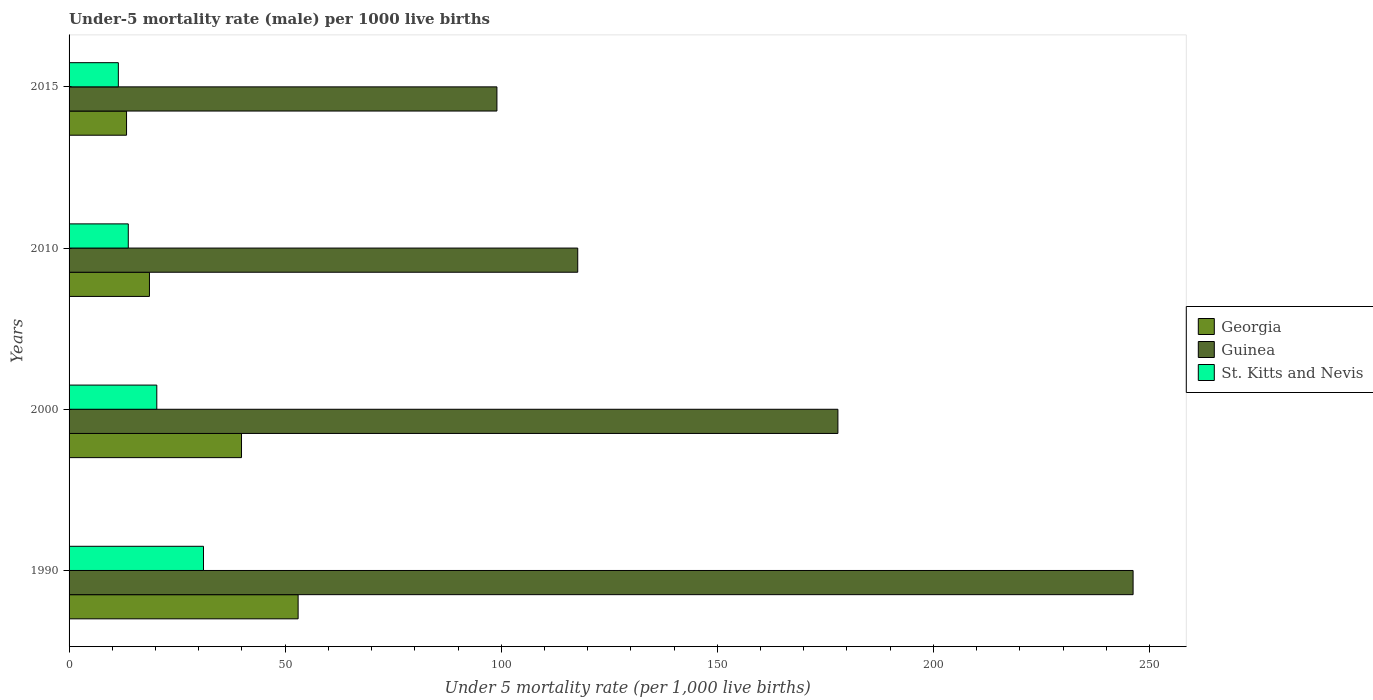How many different coloured bars are there?
Your answer should be compact. 3. How many groups of bars are there?
Your response must be concise. 4. What is the label of the 1st group of bars from the top?
Give a very brief answer. 2015. In how many cases, is the number of bars for a given year not equal to the number of legend labels?
Keep it short and to the point. 0. What is the under-five mortality rate in Guinea in 2010?
Provide a succinct answer. 117.7. In which year was the under-five mortality rate in Georgia minimum?
Make the answer very short. 2015. What is the total under-five mortality rate in Guinea in the graph?
Provide a succinct answer. 640.8. What is the difference between the under-five mortality rate in Georgia in 2000 and that in 2015?
Ensure brevity in your answer.  26.6. What is the difference between the under-five mortality rate in Georgia in 2000 and the under-five mortality rate in Guinea in 2015?
Give a very brief answer. -59.1. What is the average under-five mortality rate in Guinea per year?
Give a very brief answer. 160.2. In the year 2015, what is the difference between the under-five mortality rate in Guinea and under-five mortality rate in St. Kitts and Nevis?
Your answer should be very brief. 87.6. What is the ratio of the under-five mortality rate in Georgia in 1990 to that in 2000?
Provide a short and direct response. 1.33. What is the difference between the highest and the second highest under-five mortality rate in Guinea?
Your response must be concise. 68.3. What is the difference between the highest and the lowest under-five mortality rate in Georgia?
Make the answer very short. 39.7. In how many years, is the under-five mortality rate in Georgia greater than the average under-five mortality rate in Georgia taken over all years?
Give a very brief answer. 2. What does the 1st bar from the top in 2010 represents?
Provide a succinct answer. St. Kitts and Nevis. What does the 2nd bar from the bottom in 2015 represents?
Your response must be concise. Guinea. How many bars are there?
Provide a short and direct response. 12. Are all the bars in the graph horizontal?
Provide a short and direct response. Yes. Does the graph contain any zero values?
Make the answer very short. No. How many legend labels are there?
Keep it short and to the point. 3. How are the legend labels stacked?
Ensure brevity in your answer.  Vertical. What is the title of the graph?
Your response must be concise. Under-5 mortality rate (male) per 1000 live births. Does "Kosovo" appear as one of the legend labels in the graph?
Offer a very short reply. No. What is the label or title of the X-axis?
Provide a succinct answer. Under 5 mortality rate (per 1,0 live births). What is the label or title of the Y-axis?
Make the answer very short. Years. What is the Under 5 mortality rate (per 1,000 live births) in Guinea in 1990?
Give a very brief answer. 246.2. What is the Under 5 mortality rate (per 1,000 live births) in St. Kitts and Nevis in 1990?
Keep it short and to the point. 31.1. What is the Under 5 mortality rate (per 1,000 live births) in Georgia in 2000?
Make the answer very short. 39.9. What is the Under 5 mortality rate (per 1,000 live births) of Guinea in 2000?
Give a very brief answer. 177.9. What is the Under 5 mortality rate (per 1,000 live births) in St. Kitts and Nevis in 2000?
Offer a very short reply. 20.3. What is the Under 5 mortality rate (per 1,000 live births) of Guinea in 2010?
Your answer should be very brief. 117.7. What is the Under 5 mortality rate (per 1,000 live births) of St. Kitts and Nevis in 2010?
Provide a succinct answer. 13.7. What is the Under 5 mortality rate (per 1,000 live births) in St. Kitts and Nevis in 2015?
Ensure brevity in your answer.  11.4. Across all years, what is the maximum Under 5 mortality rate (per 1,000 live births) of Guinea?
Ensure brevity in your answer.  246.2. Across all years, what is the maximum Under 5 mortality rate (per 1,000 live births) of St. Kitts and Nevis?
Give a very brief answer. 31.1. What is the total Under 5 mortality rate (per 1,000 live births) of Georgia in the graph?
Give a very brief answer. 124.8. What is the total Under 5 mortality rate (per 1,000 live births) of Guinea in the graph?
Offer a terse response. 640.8. What is the total Under 5 mortality rate (per 1,000 live births) in St. Kitts and Nevis in the graph?
Keep it short and to the point. 76.5. What is the difference between the Under 5 mortality rate (per 1,000 live births) of Georgia in 1990 and that in 2000?
Your response must be concise. 13.1. What is the difference between the Under 5 mortality rate (per 1,000 live births) of Guinea in 1990 and that in 2000?
Provide a succinct answer. 68.3. What is the difference between the Under 5 mortality rate (per 1,000 live births) in Georgia in 1990 and that in 2010?
Your answer should be compact. 34.4. What is the difference between the Under 5 mortality rate (per 1,000 live births) in Guinea in 1990 and that in 2010?
Provide a succinct answer. 128.5. What is the difference between the Under 5 mortality rate (per 1,000 live births) in Georgia in 1990 and that in 2015?
Provide a succinct answer. 39.7. What is the difference between the Under 5 mortality rate (per 1,000 live births) in Guinea in 1990 and that in 2015?
Offer a terse response. 147.2. What is the difference between the Under 5 mortality rate (per 1,000 live births) of St. Kitts and Nevis in 1990 and that in 2015?
Your answer should be compact. 19.7. What is the difference between the Under 5 mortality rate (per 1,000 live births) of Georgia in 2000 and that in 2010?
Ensure brevity in your answer.  21.3. What is the difference between the Under 5 mortality rate (per 1,000 live births) of Guinea in 2000 and that in 2010?
Keep it short and to the point. 60.2. What is the difference between the Under 5 mortality rate (per 1,000 live births) in Georgia in 2000 and that in 2015?
Offer a terse response. 26.6. What is the difference between the Under 5 mortality rate (per 1,000 live births) of Guinea in 2000 and that in 2015?
Your answer should be compact. 78.9. What is the difference between the Under 5 mortality rate (per 1,000 live births) in St. Kitts and Nevis in 2000 and that in 2015?
Provide a short and direct response. 8.9. What is the difference between the Under 5 mortality rate (per 1,000 live births) in Georgia in 2010 and that in 2015?
Provide a short and direct response. 5.3. What is the difference between the Under 5 mortality rate (per 1,000 live births) in Guinea in 2010 and that in 2015?
Your answer should be very brief. 18.7. What is the difference between the Under 5 mortality rate (per 1,000 live births) of St. Kitts and Nevis in 2010 and that in 2015?
Your answer should be very brief. 2.3. What is the difference between the Under 5 mortality rate (per 1,000 live births) of Georgia in 1990 and the Under 5 mortality rate (per 1,000 live births) of Guinea in 2000?
Ensure brevity in your answer.  -124.9. What is the difference between the Under 5 mortality rate (per 1,000 live births) in Georgia in 1990 and the Under 5 mortality rate (per 1,000 live births) in St. Kitts and Nevis in 2000?
Offer a terse response. 32.7. What is the difference between the Under 5 mortality rate (per 1,000 live births) of Guinea in 1990 and the Under 5 mortality rate (per 1,000 live births) of St. Kitts and Nevis in 2000?
Ensure brevity in your answer.  225.9. What is the difference between the Under 5 mortality rate (per 1,000 live births) of Georgia in 1990 and the Under 5 mortality rate (per 1,000 live births) of Guinea in 2010?
Keep it short and to the point. -64.7. What is the difference between the Under 5 mortality rate (per 1,000 live births) in Georgia in 1990 and the Under 5 mortality rate (per 1,000 live births) in St. Kitts and Nevis in 2010?
Make the answer very short. 39.3. What is the difference between the Under 5 mortality rate (per 1,000 live births) in Guinea in 1990 and the Under 5 mortality rate (per 1,000 live births) in St. Kitts and Nevis in 2010?
Offer a terse response. 232.5. What is the difference between the Under 5 mortality rate (per 1,000 live births) of Georgia in 1990 and the Under 5 mortality rate (per 1,000 live births) of Guinea in 2015?
Your response must be concise. -46. What is the difference between the Under 5 mortality rate (per 1,000 live births) of Georgia in 1990 and the Under 5 mortality rate (per 1,000 live births) of St. Kitts and Nevis in 2015?
Offer a terse response. 41.6. What is the difference between the Under 5 mortality rate (per 1,000 live births) in Guinea in 1990 and the Under 5 mortality rate (per 1,000 live births) in St. Kitts and Nevis in 2015?
Offer a very short reply. 234.8. What is the difference between the Under 5 mortality rate (per 1,000 live births) in Georgia in 2000 and the Under 5 mortality rate (per 1,000 live births) in Guinea in 2010?
Make the answer very short. -77.8. What is the difference between the Under 5 mortality rate (per 1,000 live births) of Georgia in 2000 and the Under 5 mortality rate (per 1,000 live births) of St. Kitts and Nevis in 2010?
Offer a terse response. 26.2. What is the difference between the Under 5 mortality rate (per 1,000 live births) in Guinea in 2000 and the Under 5 mortality rate (per 1,000 live births) in St. Kitts and Nevis in 2010?
Give a very brief answer. 164.2. What is the difference between the Under 5 mortality rate (per 1,000 live births) in Georgia in 2000 and the Under 5 mortality rate (per 1,000 live births) in Guinea in 2015?
Keep it short and to the point. -59.1. What is the difference between the Under 5 mortality rate (per 1,000 live births) in Guinea in 2000 and the Under 5 mortality rate (per 1,000 live births) in St. Kitts and Nevis in 2015?
Your response must be concise. 166.5. What is the difference between the Under 5 mortality rate (per 1,000 live births) of Georgia in 2010 and the Under 5 mortality rate (per 1,000 live births) of Guinea in 2015?
Keep it short and to the point. -80.4. What is the difference between the Under 5 mortality rate (per 1,000 live births) in Georgia in 2010 and the Under 5 mortality rate (per 1,000 live births) in St. Kitts and Nevis in 2015?
Your answer should be compact. 7.2. What is the difference between the Under 5 mortality rate (per 1,000 live births) in Guinea in 2010 and the Under 5 mortality rate (per 1,000 live births) in St. Kitts and Nevis in 2015?
Offer a very short reply. 106.3. What is the average Under 5 mortality rate (per 1,000 live births) in Georgia per year?
Your answer should be compact. 31.2. What is the average Under 5 mortality rate (per 1,000 live births) in Guinea per year?
Ensure brevity in your answer.  160.2. What is the average Under 5 mortality rate (per 1,000 live births) of St. Kitts and Nevis per year?
Provide a succinct answer. 19.12. In the year 1990, what is the difference between the Under 5 mortality rate (per 1,000 live births) of Georgia and Under 5 mortality rate (per 1,000 live births) of Guinea?
Offer a terse response. -193.2. In the year 1990, what is the difference between the Under 5 mortality rate (per 1,000 live births) in Georgia and Under 5 mortality rate (per 1,000 live births) in St. Kitts and Nevis?
Provide a short and direct response. 21.9. In the year 1990, what is the difference between the Under 5 mortality rate (per 1,000 live births) in Guinea and Under 5 mortality rate (per 1,000 live births) in St. Kitts and Nevis?
Make the answer very short. 215.1. In the year 2000, what is the difference between the Under 5 mortality rate (per 1,000 live births) in Georgia and Under 5 mortality rate (per 1,000 live births) in Guinea?
Your answer should be compact. -138. In the year 2000, what is the difference between the Under 5 mortality rate (per 1,000 live births) of Georgia and Under 5 mortality rate (per 1,000 live births) of St. Kitts and Nevis?
Offer a very short reply. 19.6. In the year 2000, what is the difference between the Under 5 mortality rate (per 1,000 live births) of Guinea and Under 5 mortality rate (per 1,000 live births) of St. Kitts and Nevis?
Keep it short and to the point. 157.6. In the year 2010, what is the difference between the Under 5 mortality rate (per 1,000 live births) in Georgia and Under 5 mortality rate (per 1,000 live births) in Guinea?
Ensure brevity in your answer.  -99.1. In the year 2010, what is the difference between the Under 5 mortality rate (per 1,000 live births) of Georgia and Under 5 mortality rate (per 1,000 live births) of St. Kitts and Nevis?
Your answer should be very brief. 4.9. In the year 2010, what is the difference between the Under 5 mortality rate (per 1,000 live births) of Guinea and Under 5 mortality rate (per 1,000 live births) of St. Kitts and Nevis?
Make the answer very short. 104. In the year 2015, what is the difference between the Under 5 mortality rate (per 1,000 live births) in Georgia and Under 5 mortality rate (per 1,000 live births) in Guinea?
Provide a short and direct response. -85.7. In the year 2015, what is the difference between the Under 5 mortality rate (per 1,000 live births) of Georgia and Under 5 mortality rate (per 1,000 live births) of St. Kitts and Nevis?
Provide a succinct answer. 1.9. In the year 2015, what is the difference between the Under 5 mortality rate (per 1,000 live births) in Guinea and Under 5 mortality rate (per 1,000 live births) in St. Kitts and Nevis?
Give a very brief answer. 87.6. What is the ratio of the Under 5 mortality rate (per 1,000 live births) in Georgia in 1990 to that in 2000?
Your response must be concise. 1.33. What is the ratio of the Under 5 mortality rate (per 1,000 live births) in Guinea in 1990 to that in 2000?
Give a very brief answer. 1.38. What is the ratio of the Under 5 mortality rate (per 1,000 live births) in St. Kitts and Nevis in 1990 to that in 2000?
Keep it short and to the point. 1.53. What is the ratio of the Under 5 mortality rate (per 1,000 live births) of Georgia in 1990 to that in 2010?
Keep it short and to the point. 2.85. What is the ratio of the Under 5 mortality rate (per 1,000 live births) of Guinea in 1990 to that in 2010?
Offer a very short reply. 2.09. What is the ratio of the Under 5 mortality rate (per 1,000 live births) of St. Kitts and Nevis in 1990 to that in 2010?
Offer a terse response. 2.27. What is the ratio of the Under 5 mortality rate (per 1,000 live births) of Georgia in 1990 to that in 2015?
Provide a short and direct response. 3.98. What is the ratio of the Under 5 mortality rate (per 1,000 live births) in Guinea in 1990 to that in 2015?
Your answer should be very brief. 2.49. What is the ratio of the Under 5 mortality rate (per 1,000 live births) of St. Kitts and Nevis in 1990 to that in 2015?
Your answer should be compact. 2.73. What is the ratio of the Under 5 mortality rate (per 1,000 live births) in Georgia in 2000 to that in 2010?
Give a very brief answer. 2.15. What is the ratio of the Under 5 mortality rate (per 1,000 live births) in Guinea in 2000 to that in 2010?
Your answer should be compact. 1.51. What is the ratio of the Under 5 mortality rate (per 1,000 live births) of St. Kitts and Nevis in 2000 to that in 2010?
Offer a very short reply. 1.48. What is the ratio of the Under 5 mortality rate (per 1,000 live births) in Georgia in 2000 to that in 2015?
Ensure brevity in your answer.  3. What is the ratio of the Under 5 mortality rate (per 1,000 live births) of Guinea in 2000 to that in 2015?
Offer a terse response. 1.8. What is the ratio of the Under 5 mortality rate (per 1,000 live births) of St. Kitts and Nevis in 2000 to that in 2015?
Make the answer very short. 1.78. What is the ratio of the Under 5 mortality rate (per 1,000 live births) of Georgia in 2010 to that in 2015?
Make the answer very short. 1.4. What is the ratio of the Under 5 mortality rate (per 1,000 live births) of Guinea in 2010 to that in 2015?
Your response must be concise. 1.19. What is the ratio of the Under 5 mortality rate (per 1,000 live births) in St. Kitts and Nevis in 2010 to that in 2015?
Your answer should be compact. 1.2. What is the difference between the highest and the second highest Under 5 mortality rate (per 1,000 live births) of Guinea?
Provide a short and direct response. 68.3. What is the difference between the highest and the lowest Under 5 mortality rate (per 1,000 live births) of Georgia?
Make the answer very short. 39.7. What is the difference between the highest and the lowest Under 5 mortality rate (per 1,000 live births) in Guinea?
Ensure brevity in your answer.  147.2. What is the difference between the highest and the lowest Under 5 mortality rate (per 1,000 live births) in St. Kitts and Nevis?
Make the answer very short. 19.7. 